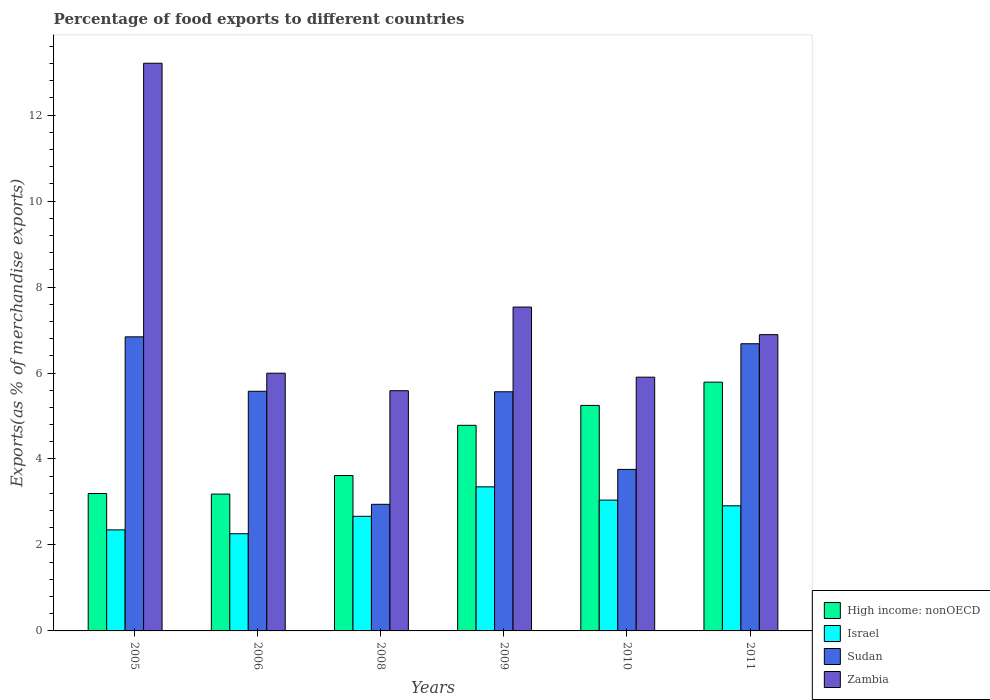Are the number of bars per tick equal to the number of legend labels?
Your answer should be compact. Yes. Are the number of bars on each tick of the X-axis equal?
Offer a terse response. Yes. How many bars are there on the 4th tick from the right?
Give a very brief answer. 4. What is the label of the 2nd group of bars from the left?
Offer a very short reply. 2006. What is the percentage of exports to different countries in Zambia in 2006?
Provide a short and direct response. 6. Across all years, what is the maximum percentage of exports to different countries in Israel?
Ensure brevity in your answer.  3.35. Across all years, what is the minimum percentage of exports to different countries in High income: nonOECD?
Provide a succinct answer. 3.18. In which year was the percentage of exports to different countries in High income: nonOECD minimum?
Make the answer very short. 2006. What is the total percentage of exports to different countries in High income: nonOECD in the graph?
Give a very brief answer. 25.81. What is the difference between the percentage of exports to different countries in Israel in 2005 and that in 2008?
Your answer should be very brief. -0.32. What is the difference between the percentage of exports to different countries in Sudan in 2010 and the percentage of exports to different countries in Israel in 2009?
Offer a very short reply. 0.41. What is the average percentage of exports to different countries in Sudan per year?
Keep it short and to the point. 5.23. In the year 2008, what is the difference between the percentage of exports to different countries in High income: nonOECD and percentage of exports to different countries in Sudan?
Provide a short and direct response. 0.67. What is the ratio of the percentage of exports to different countries in Zambia in 2009 to that in 2010?
Ensure brevity in your answer.  1.28. What is the difference between the highest and the second highest percentage of exports to different countries in Sudan?
Your answer should be compact. 0.16. What is the difference between the highest and the lowest percentage of exports to different countries in Israel?
Offer a terse response. 1.09. In how many years, is the percentage of exports to different countries in Zambia greater than the average percentage of exports to different countries in Zambia taken over all years?
Provide a succinct answer. 2. Is the sum of the percentage of exports to different countries in Sudan in 2009 and 2011 greater than the maximum percentage of exports to different countries in Israel across all years?
Your answer should be compact. Yes. Is it the case that in every year, the sum of the percentage of exports to different countries in Sudan and percentage of exports to different countries in Zambia is greater than the sum of percentage of exports to different countries in Israel and percentage of exports to different countries in High income: nonOECD?
Your answer should be very brief. Yes. What does the 2nd bar from the left in 2011 represents?
Provide a short and direct response. Israel. What does the 2nd bar from the right in 2005 represents?
Give a very brief answer. Sudan. How many bars are there?
Your response must be concise. 24. Are all the bars in the graph horizontal?
Offer a very short reply. No. How many years are there in the graph?
Provide a succinct answer. 6. Are the values on the major ticks of Y-axis written in scientific E-notation?
Ensure brevity in your answer.  No. Does the graph contain any zero values?
Provide a short and direct response. No. Does the graph contain grids?
Ensure brevity in your answer.  No. How are the legend labels stacked?
Make the answer very short. Vertical. What is the title of the graph?
Provide a short and direct response. Percentage of food exports to different countries. What is the label or title of the X-axis?
Give a very brief answer. Years. What is the label or title of the Y-axis?
Your answer should be very brief. Exports(as % of merchandise exports). What is the Exports(as % of merchandise exports) of High income: nonOECD in 2005?
Offer a terse response. 3.2. What is the Exports(as % of merchandise exports) of Israel in 2005?
Make the answer very short. 2.35. What is the Exports(as % of merchandise exports) of Sudan in 2005?
Provide a short and direct response. 6.84. What is the Exports(as % of merchandise exports) in Zambia in 2005?
Provide a short and direct response. 13.21. What is the Exports(as % of merchandise exports) in High income: nonOECD in 2006?
Ensure brevity in your answer.  3.18. What is the Exports(as % of merchandise exports) in Israel in 2006?
Offer a terse response. 2.26. What is the Exports(as % of merchandise exports) in Sudan in 2006?
Your answer should be very brief. 5.58. What is the Exports(as % of merchandise exports) in Zambia in 2006?
Provide a succinct answer. 6. What is the Exports(as % of merchandise exports) in High income: nonOECD in 2008?
Ensure brevity in your answer.  3.62. What is the Exports(as % of merchandise exports) of Israel in 2008?
Your answer should be very brief. 2.67. What is the Exports(as % of merchandise exports) in Sudan in 2008?
Your answer should be very brief. 2.95. What is the Exports(as % of merchandise exports) of Zambia in 2008?
Ensure brevity in your answer.  5.59. What is the Exports(as % of merchandise exports) in High income: nonOECD in 2009?
Give a very brief answer. 4.78. What is the Exports(as % of merchandise exports) in Israel in 2009?
Keep it short and to the point. 3.35. What is the Exports(as % of merchandise exports) in Sudan in 2009?
Provide a short and direct response. 5.56. What is the Exports(as % of merchandise exports) in Zambia in 2009?
Keep it short and to the point. 7.53. What is the Exports(as % of merchandise exports) in High income: nonOECD in 2010?
Your response must be concise. 5.25. What is the Exports(as % of merchandise exports) of Israel in 2010?
Give a very brief answer. 3.04. What is the Exports(as % of merchandise exports) in Sudan in 2010?
Offer a terse response. 3.76. What is the Exports(as % of merchandise exports) in Zambia in 2010?
Offer a very short reply. 5.9. What is the Exports(as % of merchandise exports) in High income: nonOECD in 2011?
Your answer should be very brief. 5.79. What is the Exports(as % of merchandise exports) of Israel in 2011?
Make the answer very short. 2.91. What is the Exports(as % of merchandise exports) of Sudan in 2011?
Make the answer very short. 6.68. What is the Exports(as % of merchandise exports) of Zambia in 2011?
Ensure brevity in your answer.  6.89. Across all years, what is the maximum Exports(as % of merchandise exports) of High income: nonOECD?
Make the answer very short. 5.79. Across all years, what is the maximum Exports(as % of merchandise exports) in Israel?
Your response must be concise. 3.35. Across all years, what is the maximum Exports(as % of merchandise exports) in Sudan?
Offer a very short reply. 6.84. Across all years, what is the maximum Exports(as % of merchandise exports) of Zambia?
Offer a terse response. 13.21. Across all years, what is the minimum Exports(as % of merchandise exports) of High income: nonOECD?
Make the answer very short. 3.18. Across all years, what is the minimum Exports(as % of merchandise exports) in Israel?
Offer a very short reply. 2.26. Across all years, what is the minimum Exports(as % of merchandise exports) of Sudan?
Your answer should be compact. 2.95. Across all years, what is the minimum Exports(as % of merchandise exports) of Zambia?
Your response must be concise. 5.59. What is the total Exports(as % of merchandise exports) of High income: nonOECD in the graph?
Offer a very short reply. 25.81. What is the total Exports(as % of merchandise exports) of Israel in the graph?
Ensure brevity in your answer.  16.58. What is the total Exports(as % of merchandise exports) of Sudan in the graph?
Offer a very short reply. 31.37. What is the total Exports(as % of merchandise exports) of Zambia in the graph?
Your response must be concise. 45.12. What is the difference between the Exports(as % of merchandise exports) of High income: nonOECD in 2005 and that in 2006?
Give a very brief answer. 0.01. What is the difference between the Exports(as % of merchandise exports) of Israel in 2005 and that in 2006?
Make the answer very short. 0.09. What is the difference between the Exports(as % of merchandise exports) of Sudan in 2005 and that in 2006?
Your answer should be very brief. 1.27. What is the difference between the Exports(as % of merchandise exports) in Zambia in 2005 and that in 2006?
Provide a succinct answer. 7.21. What is the difference between the Exports(as % of merchandise exports) of High income: nonOECD in 2005 and that in 2008?
Give a very brief answer. -0.42. What is the difference between the Exports(as % of merchandise exports) in Israel in 2005 and that in 2008?
Ensure brevity in your answer.  -0.32. What is the difference between the Exports(as % of merchandise exports) of Sudan in 2005 and that in 2008?
Your answer should be compact. 3.9. What is the difference between the Exports(as % of merchandise exports) in Zambia in 2005 and that in 2008?
Ensure brevity in your answer.  7.62. What is the difference between the Exports(as % of merchandise exports) of High income: nonOECD in 2005 and that in 2009?
Give a very brief answer. -1.59. What is the difference between the Exports(as % of merchandise exports) of Israel in 2005 and that in 2009?
Offer a terse response. -1. What is the difference between the Exports(as % of merchandise exports) in Sudan in 2005 and that in 2009?
Keep it short and to the point. 1.28. What is the difference between the Exports(as % of merchandise exports) of Zambia in 2005 and that in 2009?
Keep it short and to the point. 5.67. What is the difference between the Exports(as % of merchandise exports) of High income: nonOECD in 2005 and that in 2010?
Ensure brevity in your answer.  -2.05. What is the difference between the Exports(as % of merchandise exports) in Israel in 2005 and that in 2010?
Keep it short and to the point. -0.69. What is the difference between the Exports(as % of merchandise exports) in Sudan in 2005 and that in 2010?
Make the answer very short. 3.08. What is the difference between the Exports(as % of merchandise exports) in Zambia in 2005 and that in 2010?
Keep it short and to the point. 7.3. What is the difference between the Exports(as % of merchandise exports) of High income: nonOECD in 2005 and that in 2011?
Ensure brevity in your answer.  -2.59. What is the difference between the Exports(as % of merchandise exports) of Israel in 2005 and that in 2011?
Make the answer very short. -0.56. What is the difference between the Exports(as % of merchandise exports) of Sudan in 2005 and that in 2011?
Give a very brief answer. 0.16. What is the difference between the Exports(as % of merchandise exports) in Zambia in 2005 and that in 2011?
Your response must be concise. 6.31. What is the difference between the Exports(as % of merchandise exports) in High income: nonOECD in 2006 and that in 2008?
Your answer should be compact. -0.43. What is the difference between the Exports(as % of merchandise exports) in Israel in 2006 and that in 2008?
Keep it short and to the point. -0.41. What is the difference between the Exports(as % of merchandise exports) in Sudan in 2006 and that in 2008?
Give a very brief answer. 2.63. What is the difference between the Exports(as % of merchandise exports) of Zambia in 2006 and that in 2008?
Provide a short and direct response. 0.41. What is the difference between the Exports(as % of merchandise exports) of High income: nonOECD in 2006 and that in 2009?
Ensure brevity in your answer.  -1.6. What is the difference between the Exports(as % of merchandise exports) of Israel in 2006 and that in 2009?
Provide a short and direct response. -1.09. What is the difference between the Exports(as % of merchandise exports) of Sudan in 2006 and that in 2009?
Provide a succinct answer. 0.01. What is the difference between the Exports(as % of merchandise exports) of Zambia in 2006 and that in 2009?
Give a very brief answer. -1.54. What is the difference between the Exports(as % of merchandise exports) of High income: nonOECD in 2006 and that in 2010?
Keep it short and to the point. -2.06. What is the difference between the Exports(as % of merchandise exports) in Israel in 2006 and that in 2010?
Your response must be concise. -0.78. What is the difference between the Exports(as % of merchandise exports) of Sudan in 2006 and that in 2010?
Your answer should be compact. 1.82. What is the difference between the Exports(as % of merchandise exports) in Zambia in 2006 and that in 2010?
Your response must be concise. 0.09. What is the difference between the Exports(as % of merchandise exports) in High income: nonOECD in 2006 and that in 2011?
Make the answer very short. -2.6. What is the difference between the Exports(as % of merchandise exports) in Israel in 2006 and that in 2011?
Ensure brevity in your answer.  -0.65. What is the difference between the Exports(as % of merchandise exports) in Sudan in 2006 and that in 2011?
Keep it short and to the point. -1.11. What is the difference between the Exports(as % of merchandise exports) of Zambia in 2006 and that in 2011?
Your response must be concise. -0.9. What is the difference between the Exports(as % of merchandise exports) of High income: nonOECD in 2008 and that in 2009?
Keep it short and to the point. -1.17. What is the difference between the Exports(as % of merchandise exports) in Israel in 2008 and that in 2009?
Keep it short and to the point. -0.69. What is the difference between the Exports(as % of merchandise exports) in Sudan in 2008 and that in 2009?
Offer a very short reply. -2.62. What is the difference between the Exports(as % of merchandise exports) of Zambia in 2008 and that in 2009?
Make the answer very short. -1.95. What is the difference between the Exports(as % of merchandise exports) of High income: nonOECD in 2008 and that in 2010?
Keep it short and to the point. -1.63. What is the difference between the Exports(as % of merchandise exports) in Israel in 2008 and that in 2010?
Make the answer very short. -0.38. What is the difference between the Exports(as % of merchandise exports) of Sudan in 2008 and that in 2010?
Ensure brevity in your answer.  -0.81. What is the difference between the Exports(as % of merchandise exports) of Zambia in 2008 and that in 2010?
Ensure brevity in your answer.  -0.31. What is the difference between the Exports(as % of merchandise exports) of High income: nonOECD in 2008 and that in 2011?
Offer a very short reply. -2.17. What is the difference between the Exports(as % of merchandise exports) in Israel in 2008 and that in 2011?
Your answer should be compact. -0.24. What is the difference between the Exports(as % of merchandise exports) of Sudan in 2008 and that in 2011?
Provide a succinct answer. -3.74. What is the difference between the Exports(as % of merchandise exports) of Zambia in 2008 and that in 2011?
Provide a succinct answer. -1.3. What is the difference between the Exports(as % of merchandise exports) of High income: nonOECD in 2009 and that in 2010?
Your answer should be very brief. -0.46. What is the difference between the Exports(as % of merchandise exports) of Israel in 2009 and that in 2010?
Offer a terse response. 0.31. What is the difference between the Exports(as % of merchandise exports) of Sudan in 2009 and that in 2010?
Your response must be concise. 1.81. What is the difference between the Exports(as % of merchandise exports) in Zambia in 2009 and that in 2010?
Offer a very short reply. 1.63. What is the difference between the Exports(as % of merchandise exports) in High income: nonOECD in 2009 and that in 2011?
Offer a terse response. -1. What is the difference between the Exports(as % of merchandise exports) of Israel in 2009 and that in 2011?
Keep it short and to the point. 0.44. What is the difference between the Exports(as % of merchandise exports) of Sudan in 2009 and that in 2011?
Provide a short and direct response. -1.12. What is the difference between the Exports(as % of merchandise exports) in Zambia in 2009 and that in 2011?
Your answer should be compact. 0.64. What is the difference between the Exports(as % of merchandise exports) in High income: nonOECD in 2010 and that in 2011?
Make the answer very short. -0.54. What is the difference between the Exports(as % of merchandise exports) of Israel in 2010 and that in 2011?
Offer a very short reply. 0.13. What is the difference between the Exports(as % of merchandise exports) of Sudan in 2010 and that in 2011?
Give a very brief answer. -2.92. What is the difference between the Exports(as % of merchandise exports) of Zambia in 2010 and that in 2011?
Ensure brevity in your answer.  -0.99. What is the difference between the Exports(as % of merchandise exports) of High income: nonOECD in 2005 and the Exports(as % of merchandise exports) of Israel in 2006?
Keep it short and to the point. 0.94. What is the difference between the Exports(as % of merchandise exports) in High income: nonOECD in 2005 and the Exports(as % of merchandise exports) in Sudan in 2006?
Your response must be concise. -2.38. What is the difference between the Exports(as % of merchandise exports) in High income: nonOECD in 2005 and the Exports(as % of merchandise exports) in Zambia in 2006?
Your response must be concise. -2.8. What is the difference between the Exports(as % of merchandise exports) in Israel in 2005 and the Exports(as % of merchandise exports) in Sudan in 2006?
Your answer should be very brief. -3.22. What is the difference between the Exports(as % of merchandise exports) in Israel in 2005 and the Exports(as % of merchandise exports) in Zambia in 2006?
Offer a very short reply. -3.65. What is the difference between the Exports(as % of merchandise exports) in Sudan in 2005 and the Exports(as % of merchandise exports) in Zambia in 2006?
Ensure brevity in your answer.  0.85. What is the difference between the Exports(as % of merchandise exports) of High income: nonOECD in 2005 and the Exports(as % of merchandise exports) of Israel in 2008?
Your answer should be compact. 0.53. What is the difference between the Exports(as % of merchandise exports) of High income: nonOECD in 2005 and the Exports(as % of merchandise exports) of Sudan in 2008?
Provide a succinct answer. 0.25. What is the difference between the Exports(as % of merchandise exports) of High income: nonOECD in 2005 and the Exports(as % of merchandise exports) of Zambia in 2008?
Offer a very short reply. -2.39. What is the difference between the Exports(as % of merchandise exports) of Israel in 2005 and the Exports(as % of merchandise exports) of Sudan in 2008?
Your answer should be compact. -0.6. What is the difference between the Exports(as % of merchandise exports) of Israel in 2005 and the Exports(as % of merchandise exports) of Zambia in 2008?
Keep it short and to the point. -3.24. What is the difference between the Exports(as % of merchandise exports) in Sudan in 2005 and the Exports(as % of merchandise exports) in Zambia in 2008?
Your answer should be very brief. 1.25. What is the difference between the Exports(as % of merchandise exports) of High income: nonOECD in 2005 and the Exports(as % of merchandise exports) of Israel in 2009?
Keep it short and to the point. -0.15. What is the difference between the Exports(as % of merchandise exports) of High income: nonOECD in 2005 and the Exports(as % of merchandise exports) of Sudan in 2009?
Keep it short and to the point. -2.37. What is the difference between the Exports(as % of merchandise exports) in High income: nonOECD in 2005 and the Exports(as % of merchandise exports) in Zambia in 2009?
Offer a terse response. -4.34. What is the difference between the Exports(as % of merchandise exports) of Israel in 2005 and the Exports(as % of merchandise exports) of Sudan in 2009?
Your response must be concise. -3.21. What is the difference between the Exports(as % of merchandise exports) in Israel in 2005 and the Exports(as % of merchandise exports) in Zambia in 2009?
Offer a terse response. -5.18. What is the difference between the Exports(as % of merchandise exports) in Sudan in 2005 and the Exports(as % of merchandise exports) in Zambia in 2009?
Keep it short and to the point. -0.69. What is the difference between the Exports(as % of merchandise exports) of High income: nonOECD in 2005 and the Exports(as % of merchandise exports) of Israel in 2010?
Your answer should be very brief. 0.15. What is the difference between the Exports(as % of merchandise exports) in High income: nonOECD in 2005 and the Exports(as % of merchandise exports) in Sudan in 2010?
Keep it short and to the point. -0.56. What is the difference between the Exports(as % of merchandise exports) in High income: nonOECD in 2005 and the Exports(as % of merchandise exports) in Zambia in 2010?
Keep it short and to the point. -2.71. What is the difference between the Exports(as % of merchandise exports) in Israel in 2005 and the Exports(as % of merchandise exports) in Sudan in 2010?
Ensure brevity in your answer.  -1.41. What is the difference between the Exports(as % of merchandise exports) of Israel in 2005 and the Exports(as % of merchandise exports) of Zambia in 2010?
Offer a terse response. -3.55. What is the difference between the Exports(as % of merchandise exports) of Sudan in 2005 and the Exports(as % of merchandise exports) of Zambia in 2010?
Offer a very short reply. 0.94. What is the difference between the Exports(as % of merchandise exports) in High income: nonOECD in 2005 and the Exports(as % of merchandise exports) in Israel in 2011?
Keep it short and to the point. 0.29. What is the difference between the Exports(as % of merchandise exports) of High income: nonOECD in 2005 and the Exports(as % of merchandise exports) of Sudan in 2011?
Ensure brevity in your answer.  -3.48. What is the difference between the Exports(as % of merchandise exports) of High income: nonOECD in 2005 and the Exports(as % of merchandise exports) of Zambia in 2011?
Make the answer very short. -3.7. What is the difference between the Exports(as % of merchandise exports) in Israel in 2005 and the Exports(as % of merchandise exports) in Sudan in 2011?
Your response must be concise. -4.33. What is the difference between the Exports(as % of merchandise exports) in Israel in 2005 and the Exports(as % of merchandise exports) in Zambia in 2011?
Offer a very short reply. -4.54. What is the difference between the Exports(as % of merchandise exports) of Sudan in 2005 and the Exports(as % of merchandise exports) of Zambia in 2011?
Offer a terse response. -0.05. What is the difference between the Exports(as % of merchandise exports) of High income: nonOECD in 2006 and the Exports(as % of merchandise exports) of Israel in 2008?
Provide a succinct answer. 0.52. What is the difference between the Exports(as % of merchandise exports) in High income: nonOECD in 2006 and the Exports(as % of merchandise exports) in Sudan in 2008?
Your answer should be compact. 0.24. What is the difference between the Exports(as % of merchandise exports) of High income: nonOECD in 2006 and the Exports(as % of merchandise exports) of Zambia in 2008?
Offer a very short reply. -2.41. What is the difference between the Exports(as % of merchandise exports) of Israel in 2006 and the Exports(as % of merchandise exports) of Sudan in 2008?
Provide a succinct answer. -0.68. What is the difference between the Exports(as % of merchandise exports) of Israel in 2006 and the Exports(as % of merchandise exports) of Zambia in 2008?
Offer a terse response. -3.33. What is the difference between the Exports(as % of merchandise exports) of Sudan in 2006 and the Exports(as % of merchandise exports) of Zambia in 2008?
Your answer should be very brief. -0.01. What is the difference between the Exports(as % of merchandise exports) in High income: nonOECD in 2006 and the Exports(as % of merchandise exports) in Israel in 2009?
Give a very brief answer. -0.17. What is the difference between the Exports(as % of merchandise exports) in High income: nonOECD in 2006 and the Exports(as % of merchandise exports) in Sudan in 2009?
Provide a short and direct response. -2.38. What is the difference between the Exports(as % of merchandise exports) in High income: nonOECD in 2006 and the Exports(as % of merchandise exports) in Zambia in 2009?
Give a very brief answer. -4.35. What is the difference between the Exports(as % of merchandise exports) of Israel in 2006 and the Exports(as % of merchandise exports) of Sudan in 2009?
Provide a short and direct response. -3.3. What is the difference between the Exports(as % of merchandise exports) in Israel in 2006 and the Exports(as % of merchandise exports) in Zambia in 2009?
Your answer should be compact. -5.27. What is the difference between the Exports(as % of merchandise exports) in Sudan in 2006 and the Exports(as % of merchandise exports) in Zambia in 2009?
Provide a short and direct response. -1.96. What is the difference between the Exports(as % of merchandise exports) in High income: nonOECD in 2006 and the Exports(as % of merchandise exports) in Israel in 2010?
Provide a succinct answer. 0.14. What is the difference between the Exports(as % of merchandise exports) in High income: nonOECD in 2006 and the Exports(as % of merchandise exports) in Sudan in 2010?
Give a very brief answer. -0.57. What is the difference between the Exports(as % of merchandise exports) of High income: nonOECD in 2006 and the Exports(as % of merchandise exports) of Zambia in 2010?
Ensure brevity in your answer.  -2.72. What is the difference between the Exports(as % of merchandise exports) in Israel in 2006 and the Exports(as % of merchandise exports) in Sudan in 2010?
Your answer should be very brief. -1.5. What is the difference between the Exports(as % of merchandise exports) of Israel in 2006 and the Exports(as % of merchandise exports) of Zambia in 2010?
Provide a succinct answer. -3.64. What is the difference between the Exports(as % of merchandise exports) in Sudan in 2006 and the Exports(as % of merchandise exports) in Zambia in 2010?
Your response must be concise. -0.33. What is the difference between the Exports(as % of merchandise exports) of High income: nonOECD in 2006 and the Exports(as % of merchandise exports) of Israel in 2011?
Make the answer very short. 0.27. What is the difference between the Exports(as % of merchandise exports) of High income: nonOECD in 2006 and the Exports(as % of merchandise exports) of Sudan in 2011?
Keep it short and to the point. -3.5. What is the difference between the Exports(as % of merchandise exports) of High income: nonOECD in 2006 and the Exports(as % of merchandise exports) of Zambia in 2011?
Give a very brief answer. -3.71. What is the difference between the Exports(as % of merchandise exports) of Israel in 2006 and the Exports(as % of merchandise exports) of Sudan in 2011?
Provide a short and direct response. -4.42. What is the difference between the Exports(as % of merchandise exports) in Israel in 2006 and the Exports(as % of merchandise exports) in Zambia in 2011?
Give a very brief answer. -4.63. What is the difference between the Exports(as % of merchandise exports) in Sudan in 2006 and the Exports(as % of merchandise exports) in Zambia in 2011?
Offer a very short reply. -1.32. What is the difference between the Exports(as % of merchandise exports) of High income: nonOECD in 2008 and the Exports(as % of merchandise exports) of Israel in 2009?
Provide a succinct answer. 0.26. What is the difference between the Exports(as % of merchandise exports) in High income: nonOECD in 2008 and the Exports(as % of merchandise exports) in Sudan in 2009?
Make the answer very short. -1.95. What is the difference between the Exports(as % of merchandise exports) of High income: nonOECD in 2008 and the Exports(as % of merchandise exports) of Zambia in 2009?
Offer a very short reply. -3.92. What is the difference between the Exports(as % of merchandise exports) of Israel in 2008 and the Exports(as % of merchandise exports) of Sudan in 2009?
Keep it short and to the point. -2.9. What is the difference between the Exports(as % of merchandise exports) of Israel in 2008 and the Exports(as % of merchandise exports) of Zambia in 2009?
Provide a succinct answer. -4.87. What is the difference between the Exports(as % of merchandise exports) of Sudan in 2008 and the Exports(as % of merchandise exports) of Zambia in 2009?
Provide a short and direct response. -4.59. What is the difference between the Exports(as % of merchandise exports) in High income: nonOECD in 2008 and the Exports(as % of merchandise exports) in Israel in 2010?
Offer a very short reply. 0.57. What is the difference between the Exports(as % of merchandise exports) in High income: nonOECD in 2008 and the Exports(as % of merchandise exports) in Sudan in 2010?
Offer a terse response. -0.14. What is the difference between the Exports(as % of merchandise exports) in High income: nonOECD in 2008 and the Exports(as % of merchandise exports) in Zambia in 2010?
Provide a short and direct response. -2.29. What is the difference between the Exports(as % of merchandise exports) of Israel in 2008 and the Exports(as % of merchandise exports) of Sudan in 2010?
Your answer should be very brief. -1.09. What is the difference between the Exports(as % of merchandise exports) in Israel in 2008 and the Exports(as % of merchandise exports) in Zambia in 2010?
Your response must be concise. -3.24. What is the difference between the Exports(as % of merchandise exports) in Sudan in 2008 and the Exports(as % of merchandise exports) in Zambia in 2010?
Make the answer very short. -2.96. What is the difference between the Exports(as % of merchandise exports) of High income: nonOECD in 2008 and the Exports(as % of merchandise exports) of Israel in 2011?
Provide a short and direct response. 0.7. What is the difference between the Exports(as % of merchandise exports) in High income: nonOECD in 2008 and the Exports(as % of merchandise exports) in Sudan in 2011?
Give a very brief answer. -3.07. What is the difference between the Exports(as % of merchandise exports) of High income: nonOECD in 2008 and the Exports(as % of merchandise exports) of Zambia in 2011?
Provide a succinct answer. -3.28. What is the difference between the Exports(as % of merchandise exports) of Israel in 2008 and the Exports(as % of merchandise exports) of Sudan in 2011?
Keep it short and to the point. -4.01. What is the difference between the Exports(as % of merchandise exports) of Israel in 2008 and the Exports(as % of merchandise exports) of Zambia in 2011?
Make the answer very short. -4.23. What is the difference between the Exports(as % of merchandise exports) in Sudan in 2008 and the Exports(as % of merchandise exports) in Zambia in 2011?
Your answer should be compact. -3.95. What is the difference between the Exports(as % of merchandise exports) in High income: nonOECD in 2009 and the Exports(as % of merchandise exports) in Israel in 2010?
Your response must be concise. 1.74. What is the difference between the Exports(as % of merchandise exports) of High income: nonOECD in 2009 and the Exports(as % of merchandise exports) of Sudan in 2010?
Provide a short and direct response. 1.03. What is the difference between the Exports(as % of merchandise exports) in High income: nonOECD in 2009 and the Exports(as % of merchandise exports) in Zambia in 2010?
Ensure brevity in your answer.  -1.12. What is the difference between the Exports(as % of merchandise exports) of Israel in 2009 and the Exports(as % of merchandise exports) of Sudan in 2010?
Give a very brief answer. -0.41. What is the difference between the Exports(as % of merchandise exports) in Israel in 2009 and the Exports(as % of merchandise exports) in Zambia in 2010?
Your answer should be very brief. -2.55. What is the difference between the Exports(as % of merchandise exports) in Sudan in 2009 and the Exports(as % of merchandise exports) in Zambia in 2010?
Your response must be concise. -0.34. What is the difference between the Exports(as % of merchandise exports) of High income: nonOECD in 2009 and the Exports(as % of merchandise exports) of Israel in 2011?
Provide a short and direct response. 1.87. What is the difference between the Exports(as % of merchandise exports) in High income: nonOECD in 2009 and the Exports(as % of merchandise exports) in Sudan in 2011?
Give a very brief answer. -1.9. What is the difference between the Exports(as % of merchandise exports) of High income: nonOECD in 2009 and the Exports(as % of merchandise exports) of Zambia in 2011?
Make the answer very short. -2.11. What is the difference between the Exports(as % of merchandise exports) in Israel in 2009 and the Exports(as % of merchandise exports) in Sudan in 2011?
Your answer should be compact. -3.33. What is the difference between the Exports(as % of merchandise exports) in Israel in 2009 and the Exports(as % of merchandise exports) in Zambia in 2011?
Provide a short and direct response. -3.54. What is the difference between the Exports(as % of merchandise exports) of Sudan in 2009 and the Exports(as % of merchandise exports) of Zambia in 2011?
Make the answer very short. -1.33. What is the difference between the Exports(as % of merchandise exports) in High income: nonOECD in 2010 and the Exports(as % of merchandise exports) in Israel in 2011?
Provide a succinct answer. 2.34. What is the difference between the Exports(as % of merchandise exports) of High income: nonOECD in 2010 and the Exports(as % of merchandise exports) of Sudan in 2011?
Your answer should be very brief. -1.43. What is the difference between the Exports(as % of merchandise exports) of High income: nonOECD in 2010 and the Exports(as % of merchandise exports) of Zambia in 2011?
Your answer should be compact. -1.65. What is the difference between the Exports(as % of merchandise exports) of Israel in 2010 and the Exports(as % of merchandise exports) of Sudan in 2011?
Your answer should be compact. -3.64. What is the difference between the Exports(as % of merchandise exports) in Israel in 2010 and the Exports(as % of merchandise exports) in Zambia in 2011?
Your response must be concise. -3.85. What is the difference between the Exports(as % of merchandise exports) in Sudan in 2010 and the Exports(as % of merchandise exports) in Zambia in 2011?
Give a very brief answer. -3.13. What is the average Exports(as % of merchandise exports) of High income: nonOECD per year?
Offer a terse response. 4.3. What is the average Exports(as % of merchandise exports) of Israel per year?
Ensure brevity in your answer.  2.76. What is the average Exports(as % of merchandise exports) in Sudan per year?
Ensure brevity in your answer.  5.23. What is the average Exports(as % of merchandise exports) of Zambia per year?
Keep it short and to the point. 7.52. In the year 2005, what is the difference between the Exports(as % of merchandise exports) in High income: nonOECD and Exports(as % of merchandise exports) in Israel?
Give a very brief answer. 0.85. In the year 2005, what is the difference between the Exports(as % of merchandise exports) in High income: nonOECD and Exports(as % of merchandise exports) in Sudan?
Make the answer very short. -3.64. In the year 2005, what is the difference between the Exports(as % of merchandise exports) of High income: nonOECD and Exports(as % of merchandise exports) of Zambia?
Provide a short and direct response. -10.01. In the year 2005, what is the difference between the Exports(as % of merchandise exports) of Israel and Exports(as % of merchandise exports) of Sudan?
Your response must be concise. -4.49. In the year 2005, what is the difference between the Exports(as % of merchandise exports) of Israel and Exports(as % of merchandise exports) of Zambia?
Offer a very short reply. -10.86. In the year 2005, what is the difference between the Exports(as % of merchandise exports) in Sudan and Exports(as % of merchandise exports) in Zambia?
Offer a very short reply. -6.36. In the year 2006, what is the difference between the Exports(as % of merchandise exports) of High income: nonOECD and Exports(as % of merchandise exports) of Israel?
Your answer should be compact. 0.92. In the year 2006, what is the difference between the Exports(as % of merchandise exports) of High income: nonOECD and Exports(as % of merchandise exports) of Sudan?
Ensure brevity in your answer.  -2.39. In the year 2006, what is the difference between the Exports(as % of merchandise exports) in High income: nonOECD and Exports(as % of merchandise exports) in Zambia?
Make the answer very short. -2.81. In the year 2006, what is the difference between the Exports(as % of merchandise exports) of Israel and Exports(as % of merchandise exports) of Sudan?
Make the answer very short. -3.31. In the year 2006, what is the difference between the Exports(as % of merchandise exports) of Israel and Exports(as % of merchandise exports) of Zambia?
Make the answer very short. -3.73. In the year 2006, what is the difference between the Exports(as % of merchandise exports) in Sudan and Exports(as % of merchandise exports) in Zambia?
Ensure brevity in your answer.  -0.42. In the year 2008, what is the difference between the Exports(as % of merchandise exports) of High income: nonOECD and Exports(as % of merchandise exports) of Israel?
Your answer should be very brief. 0.95. In the year 2008, what is the difference between the Exports(as % of merchandise exports) in High income: nonOECD and Exports(as % of merchandise exports) in Sudan?
Your answer should be very brief. 0.67. In the year 2008, what is the difference between the Exports(as % of merchandise exports) in High income: nonOECD and Exports(as % of merchandise exports) in Zambia?
Your answer should be very brief. -1.97. In the year 2008, what is the difference between the Exports(as % of merchandise exports) in Israel and Exports(as % of merchandise exports) in Sudan?
Keep it short and to the point. -0.28. In the year 2008, what is the difference between the Exports(as % of merchandise exports) of Israel and Exports(as % of merchandise exports) of Zambia?
Keep it short and to the point. -2.92. In the year 2008, what is the difference between the Exports(as % of merchandise exports) in Sudan and Exports(as % of merchandise exports) in Zambia?
Keep it short and to the point. -2.64. In the year 2009, what is the difference between the Exports(as % of merchandise exports) of High income: nonOECD and Exports(as % of merchandise exports) of Israel?
Provide a short and direct response. 1.43. In the year 2009, what is the difference between the Exports(as % of merchandise exports) in High income: nonOECD and Exports(as % of merchandise exports) in Sudan?
Keep it short and to the point. -0.78. In the year 2009, what is the difference between the Exports(as % of merchandise exports) of High income: nonOECD and Exports(as % of merchandise exports) of Zambia?
Offer a very short reply. -2.75. In the year 2009, what is the difference between the Exports(as % of merchandise exports) of Israel and Exports(as % of merchandise exports) of Sudan?
Make the answer very short. -2.21. In the year 2009, what is the difference between the Exports(as % of merchandise exports) in Israel and Exports(as % of merchandise exports) in Zambia?
Keep it short and to the point. -4.18. In the year 2009, what is the difference between the Exports(as % of merchandise exports) of Sudan and Exports(as % of merchandise exports) of Zambia?
Keep it short and to the point. -1.97. In the year 2010, what is the difference between the Exports(as % of merchandise exports) of High income: nonOECD and Exports(as % of merchandise exports) of Israel?
Provide a succinct answer. 2.2. In the year 2010, what is the difference between the Exports(as % of merchandise exports) in High income: nonOECD and Exports(as % of merchandise exports) in Sudan?
Offer a terse response. 1.49. In the year 2010, what is the difference between the Exports(as % of merchandise exports) in High income: nonOECD and Exports(as % of merchandise exports) in Zambia?
Keep it short and to the point. -0.66. In the year 2010, what is the difference between the Exports(as % of merchandise exports) of Israel and Exports(as % of merchandise exports) of Sudan?
Keep it short and to the point. -0.71. In the year 2010, what is the difference between the Exports(as % of merchandise exports) of Israel and Exports(as % of merchandise exports) of Zambia?
Your answer should be compact. -2.86. In the year 2010, what is the difference between the Exports(as % of merchandise exports) in Sudan and Exports(as % of merchandise exports) in Zambia?
Offer a terse response. -2.15. In the year 2011, what is the difference between the Exports(as % of merchandise exports) in High income: nonOECD and Exports(as % of merchandise exports) in Israel?
Provide a succinct answer. 2.88. In the year 2011, what is the difference between the Exports(as % of merchandise exports) of High income: nonOECD and Exports(as % of merchandise exports) of Sudan?
Give a very brief answer. -0.89. In the year 2011, what is the difference between the Exports(as % of merchandise exports) of High income: nonOECD and Exports(as % of merchandise exports) of Zambia?
Your response must be concise. -1.11. In the year 2011, what is the difference between the Exports(as % of merchandise exports) of Israel and Exports(as % of merchandise exports) of Sudan?
Your answer should be compact. -3.77. In the year 2011, what is the difference between the Exports(as % of merchandise exports) in Israel and Exports(as % of merchandise exports) in Zambia?
Provide a short and direct response. -3.98. In the year 2011, what is the difference between the Exports(as % of merchandise exports) of Sudan and Exports(as % of merchandise exports) of Zambia?
Provide a succinct answer. -0.21. What is the ratio of the Exports(as % of merchandise exports) in Israel in 2005 to that in 2006?
Give a very brief answer. 1.04. What is the ratio of the Exports(as % of merchandise exports) of Sudan in 2005 to that in 2006?
Provide a short and direct response. 1.23. What is the ratio of the Exports(as % of merchandise exports) in Zambia in 2005 to that in 2006?
Make the answer very short. 2.2. What is the ratio of the Exports(as % of merchandise exports) of High income: nonOECD in 2005 to that in 2008?
Give a very brief answer. 0.88. What is the ratio of the Exports(as % of merchandise exports) in Israel in 2005 to that in 2008?
Your answer should be very brief. 0.88. What is the ratio of the Exports(as % of merchandise exports) of Sudan in 2005 to that in 2008?
Give a very brief answer. 2.32. What is the ratio of the Exports(as % of merchandise exports) in Zambia in 2005 to that in 2008?
Provide a short and direct response. 2.36. What is the ratio of the Exports(as % of merchandise exports) of High income: nonOECD in 2005 to that in 2009?
Your answer should be very brief. 0.67. What is the ratio of the Exports(as % of merchandise exports) of Israel in 2005 to that in 2009?
Provide a succinct answer. 0.7. What is the ratio of the Exports(as % of merchandise exports) of Sudan in 2005 to that in 2009?
Your response must be concise. 1.23. What is the ratio of the Exports(as % of merchandise exports) of Zambia in 2005 to that in 2009?
Your answer should be very brief. 1.75. What is the ratio of the Exports(as % of merchandise exports) in High income: nonOECD in 2005 to that in 2010?
Provide a short and direct response. 0.61. What is the ratio of the Exports(as % of merchandise exports) of Israel in 2005 to that in 2010?
Your response must be concise. 0.77. What is the ratio of the Exports(as % of merchandise exports) of Sudan in 2005 to that in 2010?
Offer a terse response. 1.82. What is the ratio of the Exports(as % of merchandise exports) of Zambia in 2005 to that in 2010?
Your answer should be compact. 2.24. What is the ratio of the Exports(as % of merchandise exports) of High income: nonOECD in 2005 to that in 2011?
Offer a terse response. 0.55. What is the ratio of the Exports(as % of merchandise exports) of Israel in 2005 to that in 2011?
Give a very brief answer. 0.81. What is the ratio of the Exports(as % of merchandise exports) of Zambia in 2005 to that in 2011?
Offer a very short reply. 1.92. What is the ratio of the Exports(as % of merchandise exports) of High income: nonOECD in 2006 to that in 2008?
Provide a short and direct response. 0.88. What is the ratio of the Exports(as % of merchandise exports) in Israel in 2006 to that in 2008?
Keep it short and to the point. 0.85. What is the ratio of the Exports(as % of merchandise exports) of Sudan in 2006 to that in 2008?
Your response must be concise. 1.89. What is the ratio of the Exports(as % of merchandise exports) in Zambia in 2006 to that in 2008?
Your response must be concise. 1.07. What is the ratio of the Exports(as % of merchandise exports) in High income: nonOECD in 2006 to that in 2009?
Your response must be concise. 0.67. What is the ratio of the Exports(as % of merchandise exports) in Israel in 2006 to that in 2009?
Ensure brevity in your answer.  0.67. What is the ratio of the Exports(as % of merchandise exports) of Zambia in 2006 to that in 2009?
Provide a succinct answer. 0.8. What is the ratio of the Exports(as % of merchandise exports) in High income: nonOECD in 2006 to that in 2010?
Your answer should be compact. 0.61. What is the ratio of the Exports(as % of merchandise exports) in Israel in 2006 to that in 2010?
Provide a short and direct response. 0.74. What is the ratio of the Exports(as % of merchandise exports) in Sudan in 2006 to that in 2010?
Your answer should be compact. 1.48. What is the ratio of the Exports(as % of merchandise exports) in Zambia in 2006 to that in 2010?
Give a very brief answer. 1.02. What is the ratio of the Exports(as % of merchandise exports) of High income: nonOECD in 2006 to that in 2011?
Offer a very short reply. 0.55. What is the ratio of the Exports(as % of merchandise exports) in Israel in 2006 to that in 2011?
Give a very brief answer. 0.78. What is the ratio of the Exports(as % of merchandise exports) of Sudan in 2006 to that in 2011?
Your response must be concise. 0.83. What is the ratio of the Exports(as % of merchandise exports) of Zambia in 2006 to that in 2011?
Your answer should be very brief. 0.87. What is the ratio of the Exports(as % of merchandise exports) of High income: nonOECD in 2008 to that in 2009?
Your answer should be very brief. 0.76. What is the ratio of the Exports(as % of merchandise exports) in Israel in 2008 to that in 2009?
Make the answer very short. 0.8. What is the ratio of the Exports(as % of merchandise exports) of Sudan in 2008 to that in 2009?
Offer a very short reply. 0.53. What is the ratio of the Exports(as % of merchandise exports) of Zambia in 2008 to that in 2009?
Ensure brevity in your answer.  0.74. What is the ratio of the Exports(as % of merchandise exports) of High income: nonOECD in 2008 to that in 2010?
Keep it short and to the point. 0.69. What is the ratio of the Exports(as % of merchandise exports) of Israel in 2008 to that in 2010?
Make the answer very short. 0.88. What is the ratio of the Exports(as % of merchandise exports) of Sudan in 2008 to that in 2010?
Give a very brief answer. 0.78. What is the ratio of the Exports(as % of merchandise exports) in Zambia in 2008 to that in 2010?
Keep it short and to the point. 0.95. What is the ratio of the Exports(as % of merchandise exports) of High income: nonOECD in 2008 to that in 2011?
Your response must be concise. 0.62. What is the ratio of the Exports(as % of merchandise exports) in Israel in 2008 to that in 2011?
Provide a short and direct response. 0.92. What is the ratio of the Exports(as % of merchandise exports) in Sudan in 2008 to that in 2011?
Your answer should be very brief. 0.44. What is the ratio of the Exports(as % of merchandise exports) of Zambia in 2008 to that in 2011?
Keep it short and to the point. 0.81. What is the ratio of the Exports(as % of merchandise exports) of High income: nonOECD in 2009 to that in 2010?
Provide a short and direct response. 0.91. What is the ratio of the Exports(as % of merchandise exports) of Israel in 2009 to that in 2010?
Ensure brevity in your answer.  1.1. What is the ratio of the Exports(as % of merchandise exports) in Sudan in 2009 to that in 2010?
Ensure brevity in your answer.  1.48. What is the ratio of the Exports(as % of merchandise exports) of Zambia in 2009 to that in 2010?
Offer a very short reply. 1.28. What is the ratio of the Exports(as % of merchandise exports) in High income: nonOECD in 2009 to that in 2011?
Your response must be concise. 0.83. What is the ratio of the Exports(as % of merchandise exports) of Israel in 2009 to that in 2011?
Your response must be concise. 1.15. What is the ratio of the Exports(as % of merchandise exports) in Sudan in 2009 to that in 2011?
Offer a very short reply. 0.83. What is the ratio of the Exports(as % of merchandise exports) in Zambia in 2009 to that in 2011?
Your answer should be very brief. 1.09. What is the ratio of the Exports(as % of merchandise exports) of High income: nonOECD in 2010 to that in 2011?
Your answer should be compact. 0.91. What is the ratio of the Exports(as % of merchandise exports) in Israel in 2010 to that in 2011?
Your answer should be compact. 1.05. What is the ratio of the Exports(as % of merchandise exports) of Sudan in 2010 to that in 2011?
Offer a very short reply. 0.56. What is the ratio of the Exports(as % of merchandise exports) in Zambia in 2010 to that in 2011?
Give a very brief answer. 0.86. What is the difference between the highest and the second highest Exports(as % of merchandise exports) in High income: nonOECD?
Offer a terse response. 0.54. What is the difference between the highest and the second highest Exports(as % of merchandise exports) in Israel?
Ensure brevity in your answer.  0.31. What is the difference between the highest and the second highest Exports(as % of merchandise exports) in Sudan?
Make the answer very short. 0.16. What is the difference between the highest and the second highest Exports(as % of merchandise exports) in Zambia?
Give a very brief answer. 5.67. What is the difference between the highest and the lowest Exports(as % of merchandise exports) of High income: nonOECD?
Provide a succinct answer. 2.6. What is the difference between the highest and the lowest Exports(as % of merchandise exports) of Israel?
Provide a succinct answer. 1.09. What is the difference between the highest and the lowest Exports(as % of merchandise exports) of Sudan?
Give a very brief answer. 3.9. What is the difference between the highest and the lowest Exports(as % of merchandise exports) of Zambia?
Offer a very short reply. 7.62. 